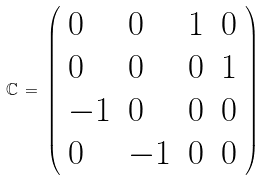<formula> <loc_0><loc_0><loc_500><loc_500>\mathbb { C } \, = \, \left ( \begin{array} { l l l l } 0 & 0 & 1 & 0 \\ 0 & 0 & 0 & 1 \\ - 1 & 0 & 0 & 0 \\ 0 & - 1 & 0 & 0 \end{array} \right )</formula> 